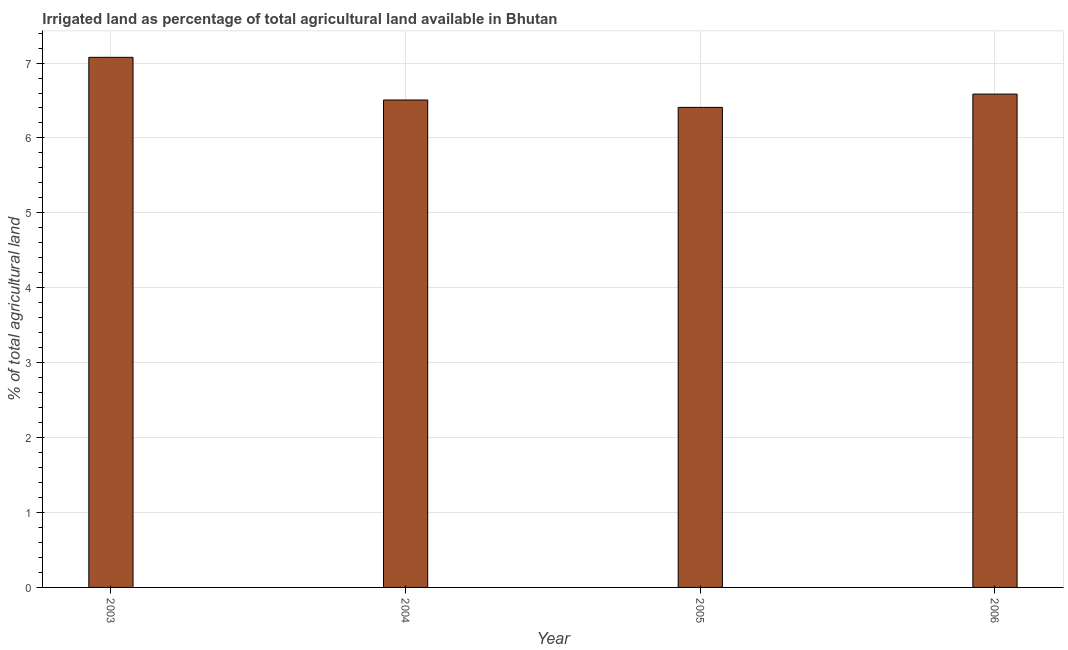What is the title of the graph?
Ensure brevity in your answer.  Irrigated land as percentage of total agricultural land available in Bhutan. What is the label or title of the Y-axis?
Your response must be concise. % of total agricultural land. What is the percentage of agricultural irrigated land in 2005?
Offer a very short reply. 6.41. Across all years, what is the maximum percentage of agricultural irrigated land?
Ensure brevity in your answer.  7.08. Across all years, what is the minimum percentage of agricultural irrigated land?
Provide a succinct answer. 6.41. In which year was the percentage of agricultural irrigated land maximum?
Offer a very short reply. 2003. What is the sum of the percentage of agricultural irrigated land?
Offer a very short reply. 26.58. What is the difference between the percentage of agricultural irrigated land in 2003 and 2005?
Keep it short and to the point. 0.67. What is the average percentage of agricultural irrigated land per year?
Keep it short and to the point. 6.64. What is the median percentage of agricultural irrigated land?
Your answer should be compact. 6.55. Do a majority of the years between 2006 and 2004 (inclusive) have percentage of agricultural irrigated land greater than 3.6 %?
Your answer should be very brief. Yes. What is the ratio of the percentage of agricultural irrigated land in 2003 to that in 2004?
Your answer should be compact. 1.09. Is the percentage of agricultural irrigated land in 2003 less than that in 2005?
Keep it short and to the point. No. Is the difference between the percentage of agricultural irrigated land in 2004 and 2006 greater than the difference between any two years?
Your answer should be compact. No. What is the difference between the highest and the second highest percentage of agricultural irrigated land?
Your response must be concise. 0.49. What is the difference between the highest and the lowest percentage of agricultural irrigated land?
Your answer should be very brief. 0.67. In how many years, is the percentage of agricultural irrigated land greater than the average percentage of agricultural irrigated land taken over all years?
Make the answer very short. 1. Are all the bars in the graph horizontal?
Your answer should be compact. No. What is the difference between two consecutive major ticks on the Y-axis?
Make the answer very short. 1. Are the values on the major ticks of Y-axis written in scientific E-notation?
Ensure brevity in your answer.  No. What is the % of total agricultural land in 2003?
Offer a terse response. 7.08. What is the % of total agricultural land in 2004?
Your answer should be compact. 6.51. What is the % of total agricultural land of 2005?
Ensure brevity in your answer.  6.41. What is the % of total agricultural land of 2006?
Give a very brief answer. 6.59. What is the difference between the % of total agricultural land in 2003 and 2004?
Provide a short and direct response. 0.57. What is the difference between the % of total agricultural land in 2003 and 2005?
Keep it short and to the point. 0.67. What is the difference between the % of total agricultural land in 2003 and 2006?
Make the answer very short. 0.49. What is the difference between the % of total agricultural land in 2004 and 2005?
Your response must be concise. 0.1. What is the difference between the % of total agricultural land in 2004 and 2006?
Offer a terse response. -0.08. What is the difference between the % of total agricultural land in 2005 and 2006?
Offer a terse response. -0.18. What is the ratio of the % of total agricultural land in 2003 to that in 2004?
Offer a terse response. 1.09. What is the ratio of the % of total agricultural land in 2003 to that in 2005?
Keep it short and to the point. 1.1. What is the ratio of the % of total agricultural land in 2003 to that in 2006?
Offer a terse response. 1.07. What is the ratio of the % of total agricultural land in 2004 to that in 2006?
Ensure brevity in your answer.  0.99. 